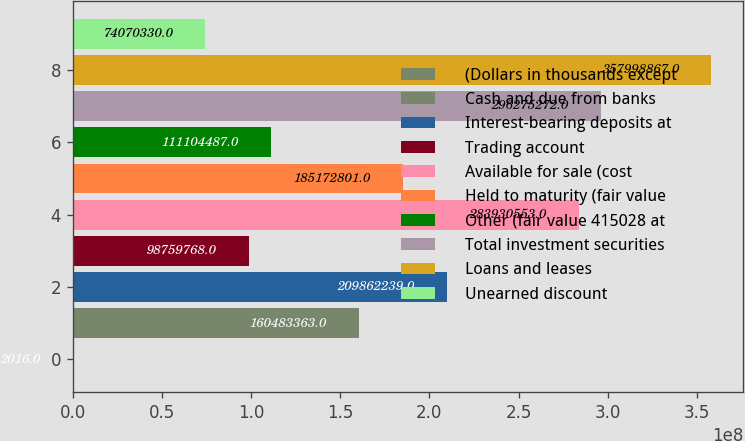Convert chart. <chart><loc_0><loc_0><loc_500><loc_500><bar_chart><fcel>(Dollars in thousands except<fcel>Cash and due from banks<fcel>Interest-bearing deposits at<fcel>Trading account<fcel>Available for sale (cost<fcel>Held to maturity (fair value<fcel>Other (fair value 415028 at<fcel>Total investment securities<fcel>Loans and leases<fcel>Unearned discount<nl><fcel>2016<fcel>1.60483e+08<fcel>2.09862e+08<fcel>9.87598e+07<fcel>2.83931e+08<fcel>1.85173e+08<fcel>1.11104e+08<fcel>2.96275e+08<fcel>3.57999e+08<fcel>7.40703e+07<nl></chart> 